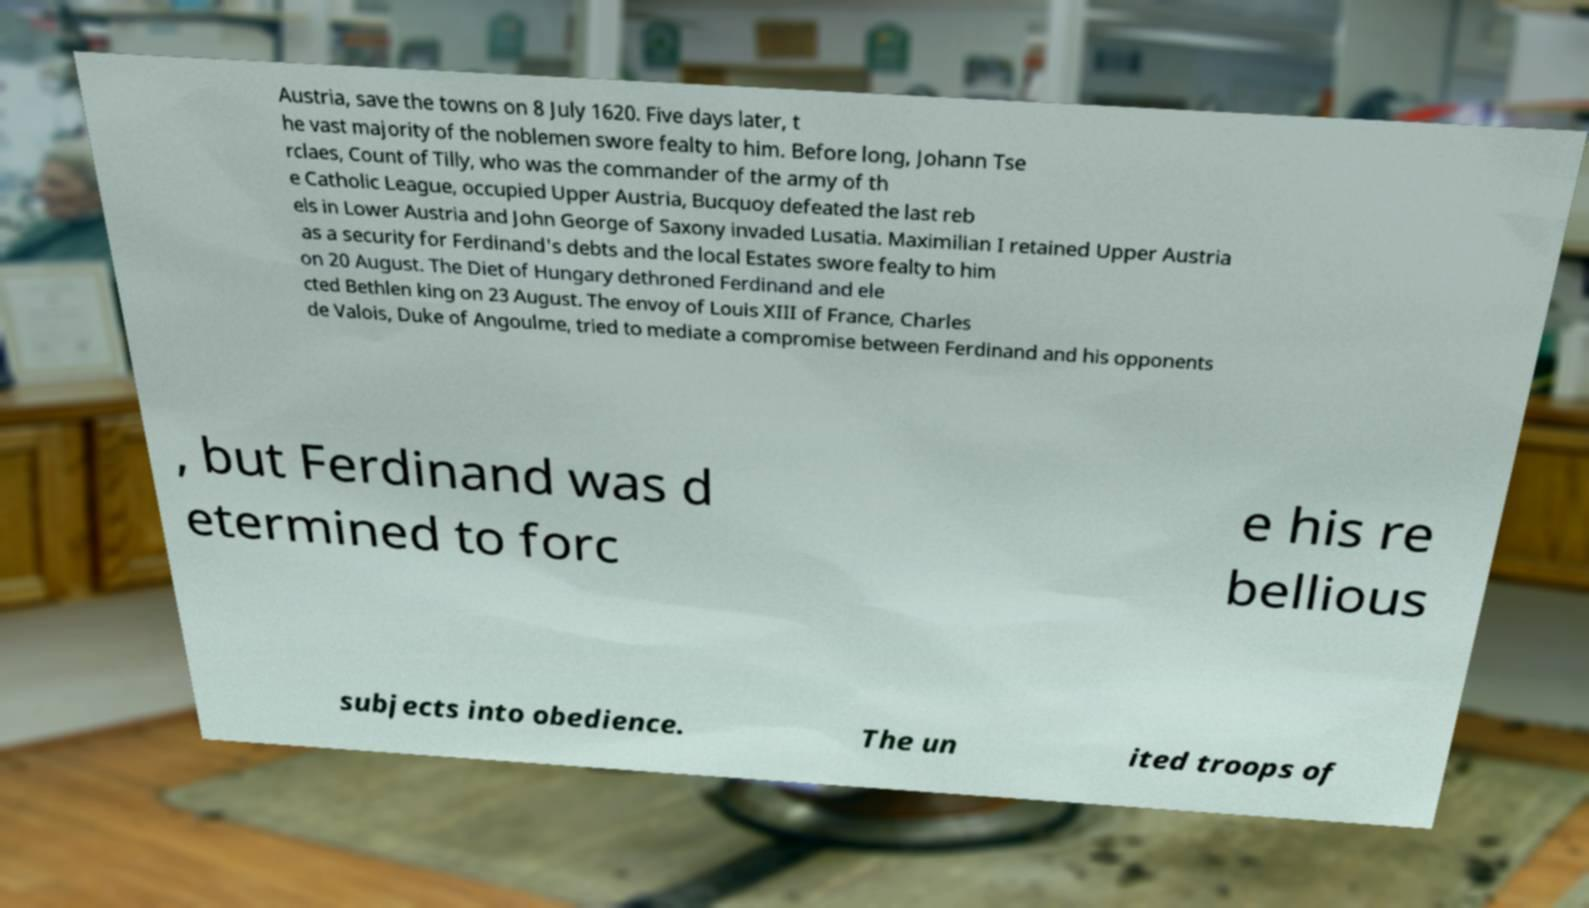There's text embedded in this image that I need extracted. Can you transcribe it verbatim? Austria, save the towns on 8 July 1620. Five days later, t he vast majority of the noblemen swore fealty to him. Before long, Johann Tse rclaes, Count of Tilly, who was the commander of the army of th e Catholic League, occupied Upper Austria, Bucquoy defeated the last reb els in Lower Austria and John George of Saxony invaded Lusatia. Maximilian I retained Upper Austria as a security for Ferdinand's debts and the local Estates swore fealty to him on 20 August. The Diet of Hungary dethroned Ferdinand and ele cted Bethlen king on 23 August. The envoy of Louis XIII of France, Charles de Valois, Duke of Angoulme, tried to mediate a compromise between Ferdinand and his opponents , but Ferdinand was d etermined to forc e his re bellious subjects into obedience. The un ited troops of 